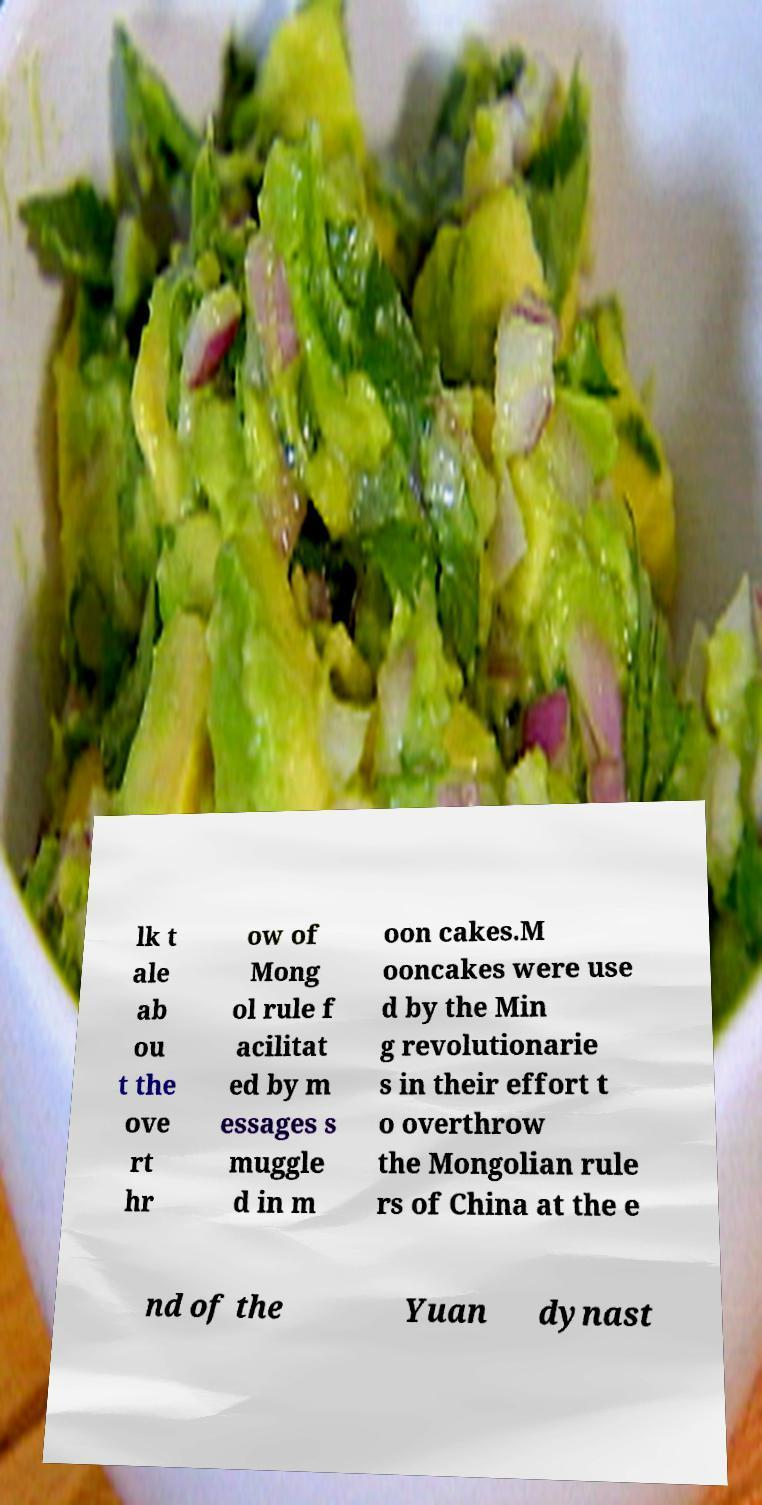Can you read and provide the text displayed in the image?This photo seems to have some interesting text. Can you extract and type it out for me? lk t ale ab ou t the ove rt hr ow of Mong ol rule f acilitat ed by m essages s muggle d in m oon cakes.M ooncakes were use d by the Min g revolutionarie s in their effort t o overthrow the Mongolian rule rs of China at the e nd of the Yuan dynast 